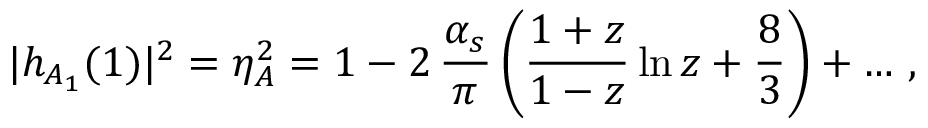<formula> <loc_0><loc_0><loc_500><loc_500>| h _ { A _ { 1 } } ( 1 ) | ^ { 2 } = \eta _ { A } ^ { 2 } = 1 - 2 \, { \frac { \alpha _ { s } } { \pi } } \, \left ( { \frac { 1 + z } { 1 - z } } \ln z + \frac { 8 } { 3 } \right ) + \dots \, ,</formula> 